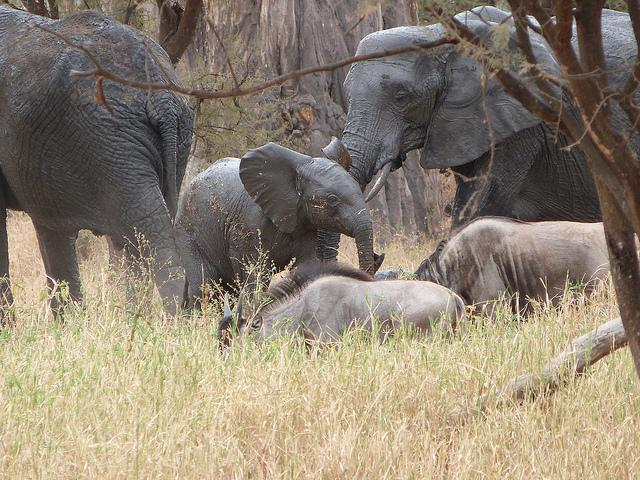What feature do these animals have? tusks 